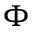<formula> <loc_0><loc_0><loc_500><loc_500>\Phi</formula> 